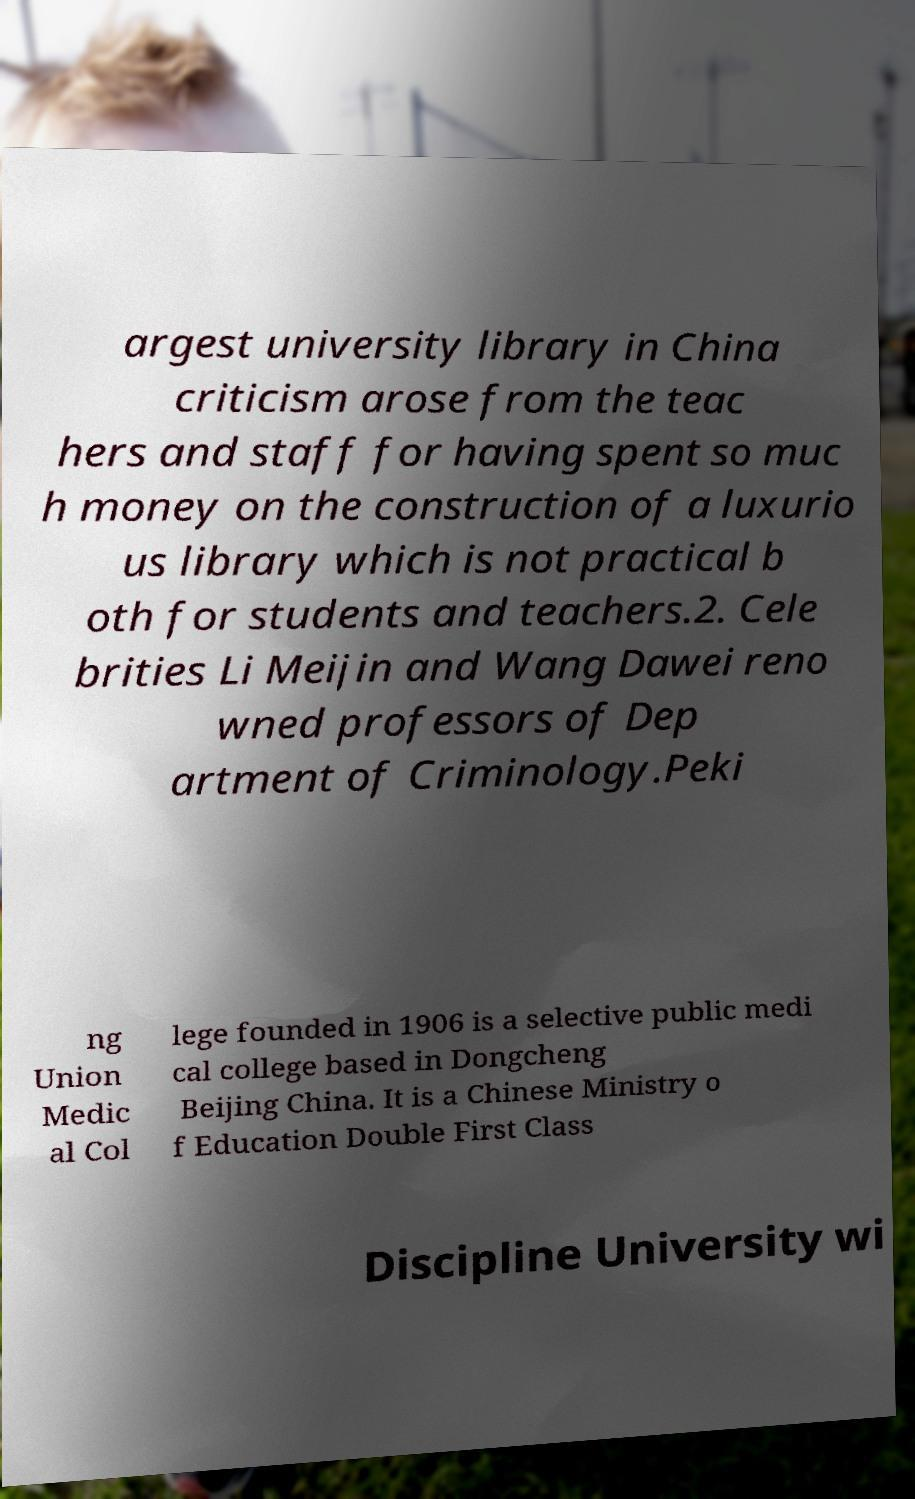Could you assist in decoding the text presented in this image and type it out clearly? argest university library in China criticism arose from the teac hers and staff for having spent so muc h money on the construction of a luxurio us library which is not practical b oth for students and teachers.2. Cele brities Li Meijin and Wang Dawei reno wned professors of Dep artment of Criminology.Peki ng Union Medic al Col lege founded in 1906 is a selective public medi cal college based in Dongcheng Beijing China. It is a Chinese Ministry o f Education Double First Class Discipline University wi 